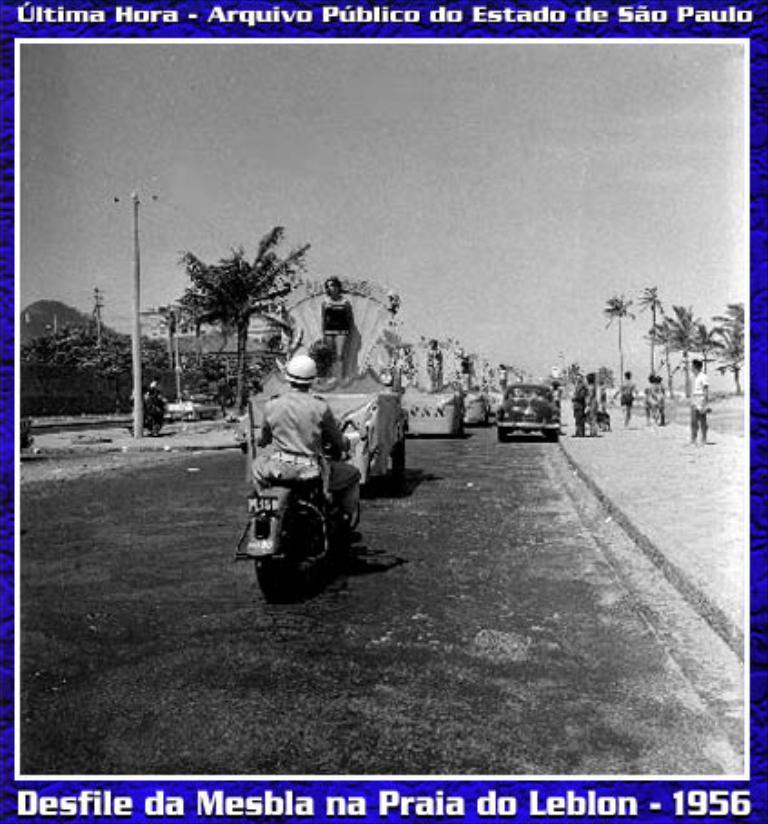In one or two sentences, can you explain what this image depicts? This is an edited image. We can see there are vehicles on the road. On the right side of the image, a group of people standing on the walkway. On the left side of the image, there are trees and there is an electric pole with cables. Behind the trees, there is the sky. On the image, there are watermarks. 